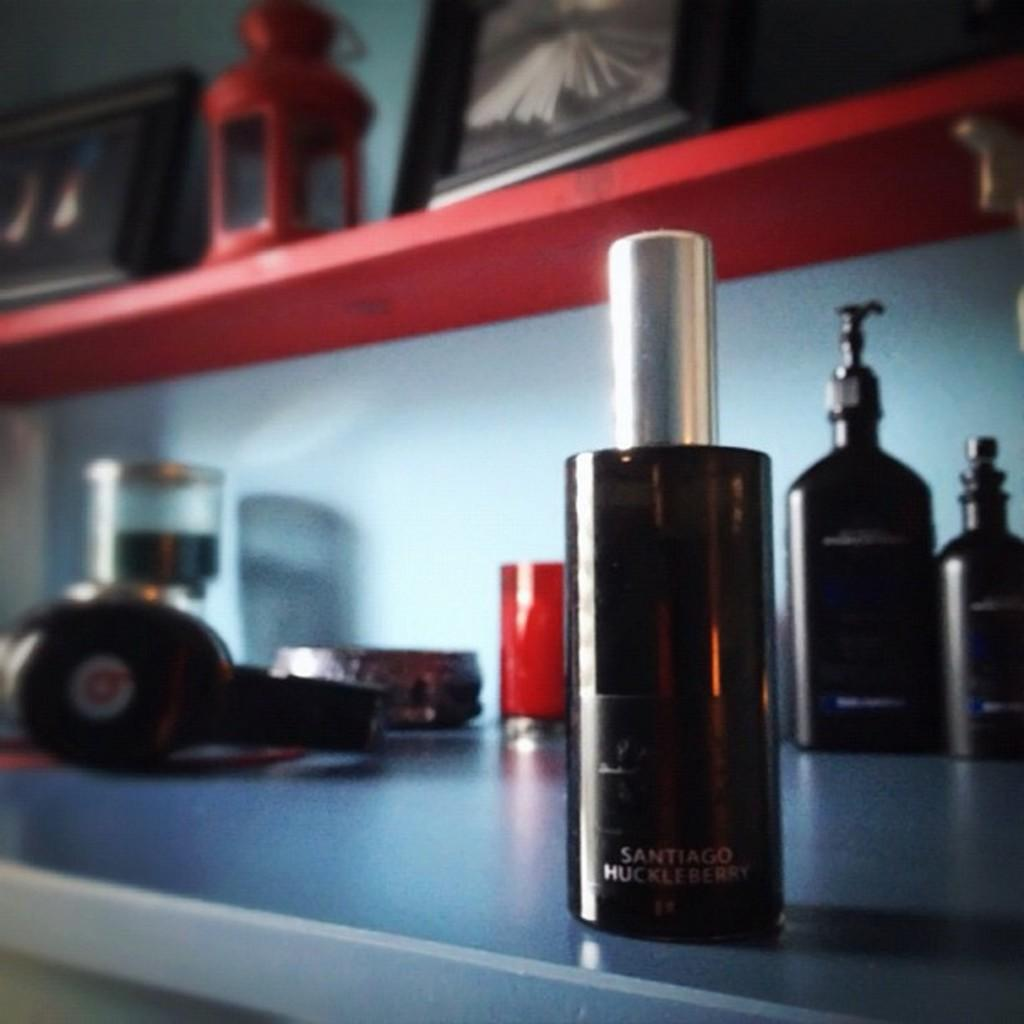What is the main object in the image? There is a perfume bottle in the image. Where is the perfume bottle located? The perfume bottle is in a rack. What other items can be seen in the image? There is a headphone, a photo frame, and a red color lantern visible in the image. How many lizards are crawling on the perfume bottle in the image? There are no lizards present in the image. What is the perfume bottle doing to the person's throat in the image? The perfume bottle is not interacting with a person's throat in the image; it is simply sitting in a rack. 